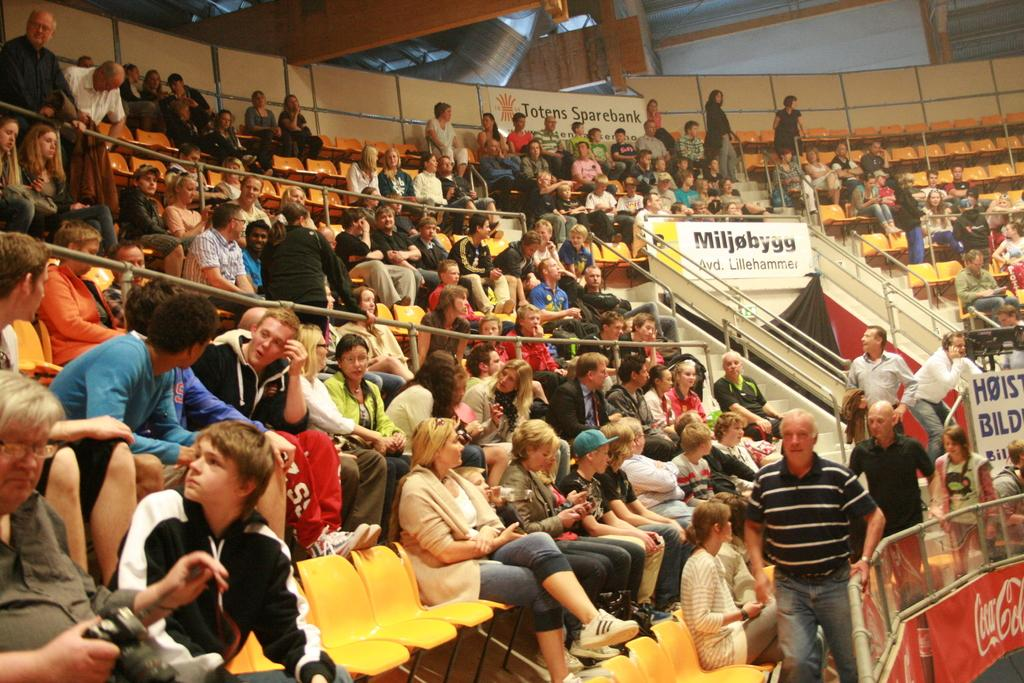Who or what can be seen in the image? There are people in the image. What can be used for sitting in the image? There are chairs in the image. What can be used for support or safety in the image? There are railings in the image. What can be used for climbing or descending in the image? There are steps in the image. What can be used for advertising or displaying information in the image? There are hoardings in the image. What objects are present in the image? Some objects are present in the image. What are some people doing in the image? Some people are standing in the image. What can be found on the hoardings in the image? There is writing on the hoardings. Can you see a hole in the image? There is no mention of a hole in the provided facts, so it cannot be determined if a hole is present in the image. What type of transport is being used by the people in the image? There is no mention of any transport in the provided facts, so it cannot be determined if any transport is present in the image. 